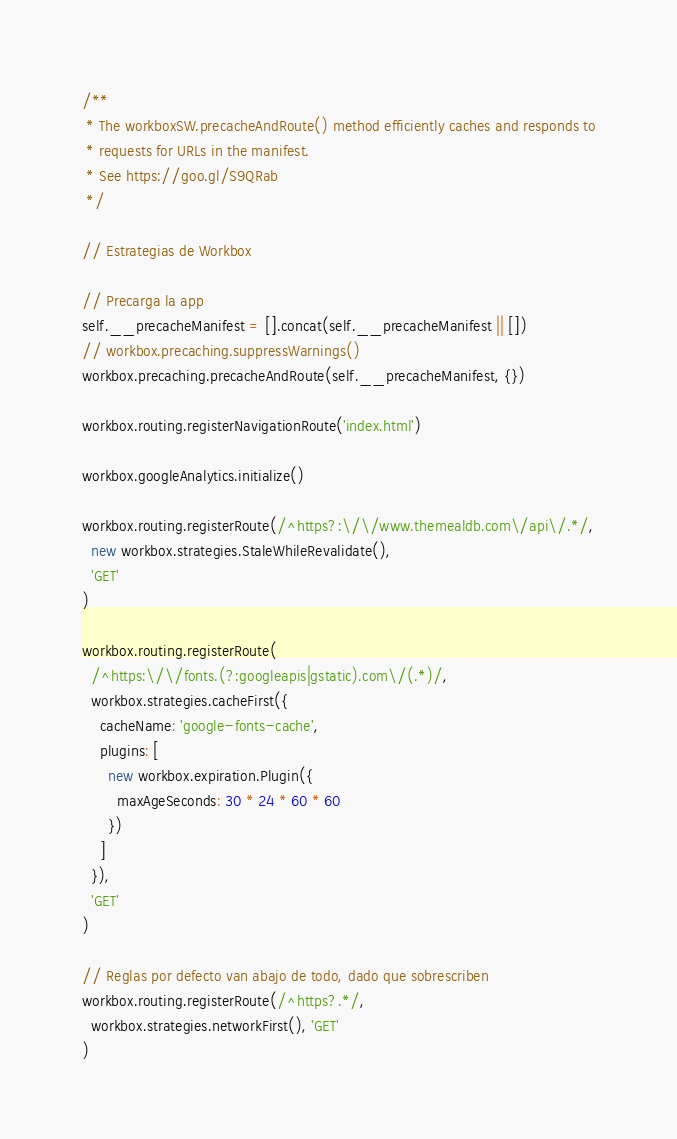<code> <loc_0><loc_0><loc_500><loc_500><_JavaScript_>/**
 * The workboxSW.precacheAndRoute() method efficiently caches and responds to
 * requests for URLs in the manifest.
 * See https://goo.gl/S9QRab
 */

// Estrategias de Workbox

// Precarga la app
self.__precacheManifest = [].concat(self.__precacheManifest || [])
// workbox.precaching.suppressWarnings()
workbox.precaching.precacheAndRoute(self.__precacheManifest, {})

workbox.routing.registerNavigationRoute('index.html')

workbox.googleAnalytics.initialize()

workbox.routing.registerRoute(/^https?:\/\/www.themealdb.com\/api\/.*/,
  new workbox.strategies.StaleWhileRevalidate(),
  'GET'
)

workbox.routing.registerRoute(
  /^https:\/\/fonts.(?:googleapis|gstatic).com\/(.*)/,
  workbox.strategies.cacheFirst({
    cacheName: 'google-fonts-cache',
    plugins: [
      new workbox.expiration.Plugin({
        maxAgeSeconds: 30 * 24 * 60 * 60
      })
    ]
  }),
  'GET'
)

// Reglas por defecto van abajo de todo, dado que sobrescriben
workbox.routing.registerRoute(/^https?.*/,
  workbox.strategies.networkFirst(), 'GET'
)</code> 